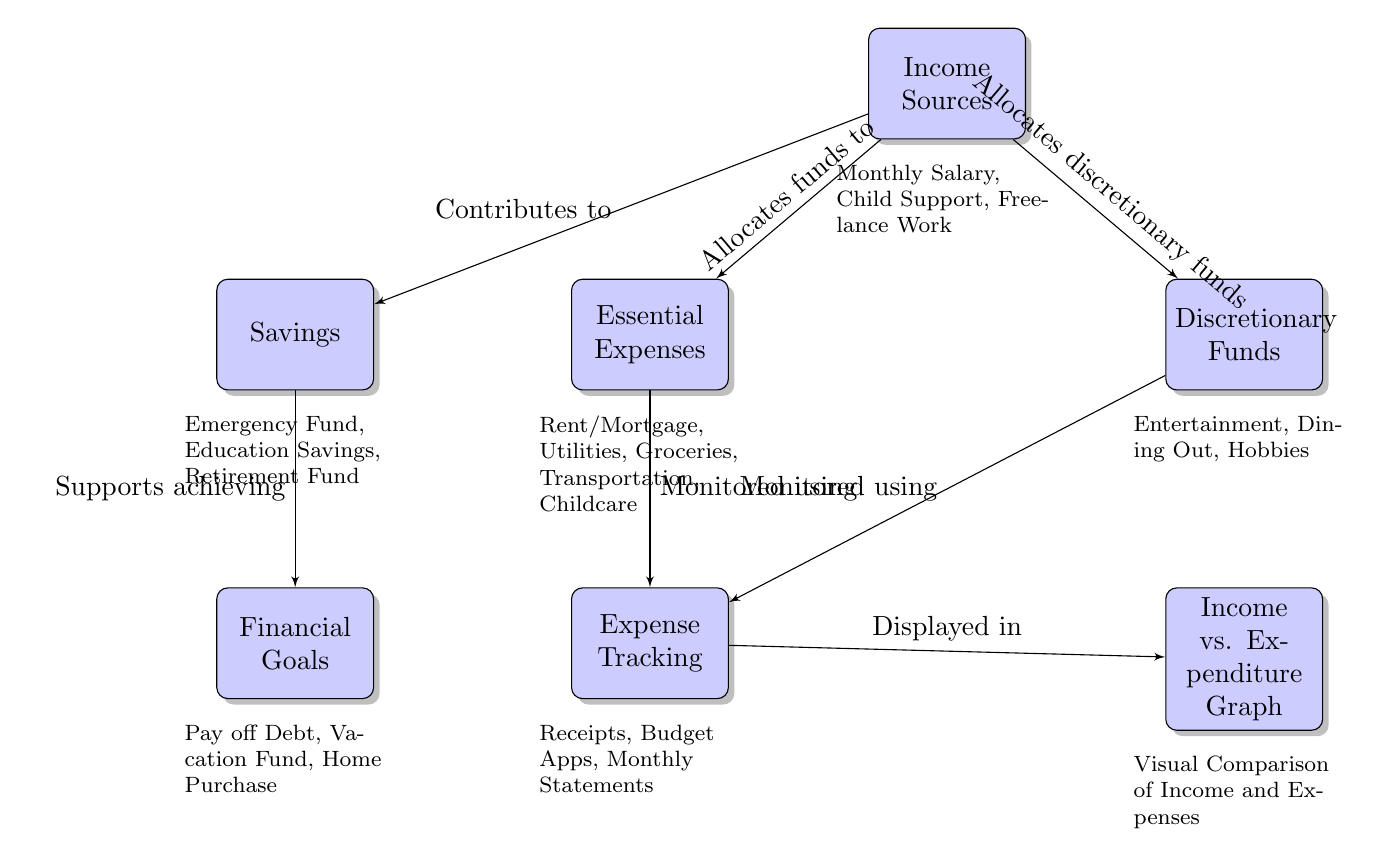What are the main income sources listed? The diagram identifies three main income sources: Monthly Salary, Child Support, and Freelance Work. These are specifically mentioned as components under the "Income Sources" block.
Answer: Monthly Salary, Child Support, Freelance Work What are the essential expenses in the diagram? The essential expenses mentioned in the diagram include Rent/Mortgage, Utilities, Groceries, Transportation, and Childcare. These are listed under the "Essential Expenses" block.
Answer: Rent/Mortgage, Utilities, Groceries, Transportation, Childcare How many blocks are there in the diagram? The diagram consists of six main blocks, which represent various components involved in budget planning and expense tracking. The blocks are: Income Sources, Essential Expenses, Discretionary Funds, Expense Tracking, Income vs. Expenditure Graph, Savings, and Financial Goals.
Answer: 6 What is tracked using receipts, budget apps, and monthly statements? The diagram states that "Expense Tracking" is monitored using Receipts, Budget Apps, and Monthly Statements, indicating methods used to keep track of financial expenditure.
Answer: Expense Tracking What supports achieving financial goals? According to the diagram, Savings is indicated as the element that supports achieving Financial Goals, establishing a direct link from one to the other.
Answer: Savings Which block receives funds allocated from the income source? The "Essential Expenses" block receives funds that are allocated from the "Income Sources" block, as indicated by the directed arrow in the diagram.
Answer: Essential Expenses What visual representation is displayed in the Income vs. Expenditure Graph? The graph visualizes the comparison of income and expenses, providing a visual interpretation of financial data over a specific period.
Answer: Visual Comparison of Income and Expenses What are the components of discretionary funds? The discretionary funds include Entertainment, Dining Out, and Hobbies, as detailed in the "Discretionary Funds" block of the diagram.
Answer: Entertainment, Dining Out, Hobbies How does income contribute to savings? The diagram shows that income directly contributes to savings, as depicted by the arrow connecting "Income Sources" to "Savings," indicating funding allocation.
Answer: Contributes to What financial objectives are linked to savings? The diagram connects Savings to Financial Goals, supporting objectives such as "Pay off Debt," "Vacation Fund," and "Home Purchase." These goals are dependent on the savings accrued.
Answer: Financial Goals 